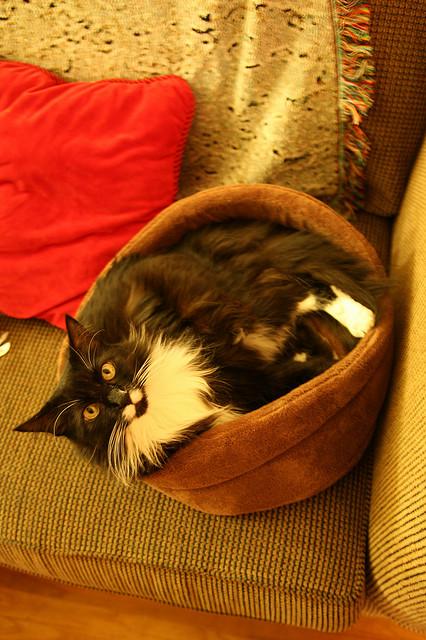What is the pattern on the chair?
Give a very brief answer. Striped. Is this cat sleeping?
Be succinct. No. What type of cat is this?
Answer briefly. Long hair. What color is the 'moustache'?
Be succinct. White. 